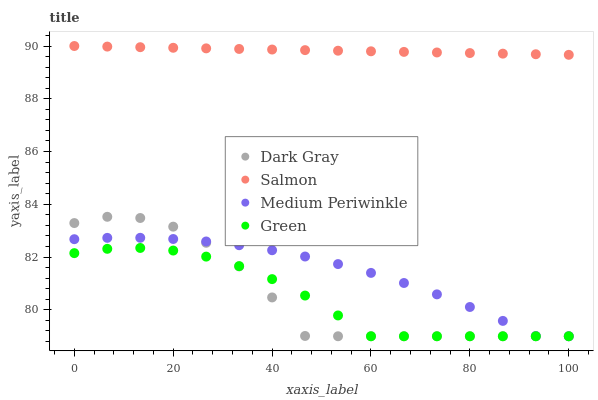Does Green have the minimum area under the curve?
Answer yes or no. Yes. Does Salmon have the maximum area under the curve?
Answer yes or no. Yes. Does Medium Periwinkle have the minimum area under the curve?
Answer yes or no. No. Does Medium Periwinkle have the maximum area under the curve?
Answer yes or no. No. Is Salmon the smoothest?
Answer yes or no. Yes. Is Dark Gray the roughest?
Answer yes or no. Yes. Is Medium Periwinkle the smoothest?
Answer yes or no. No. Is Medium Periwinkle the roughest?
Answer yes or no. No. Does Dark Gray have the lowest value?
Answer yes or no. Yes. Does Salmon have the lowest value?
Answer yes or no. No. Does Salmon have the highest value?
Answer yes or no. Yes. Does Medium Periwinkle have the highest value?
Answer yes or no. No. Is Dark Gray less than Salmon?
Answer yes or no. Yes. Is Salmon greater than Dark Gray?
Answer yes or no. Yes. Does Green intersect Dark Gray?
Answer yes or no. Yes. Is Green less than Dark Gray?
Answer yes or no. No. Is Green greater than Dark Gray?
Answer yes or no. No. Does Dark Gray intersect Salmon?
Answer yes or no. No. 